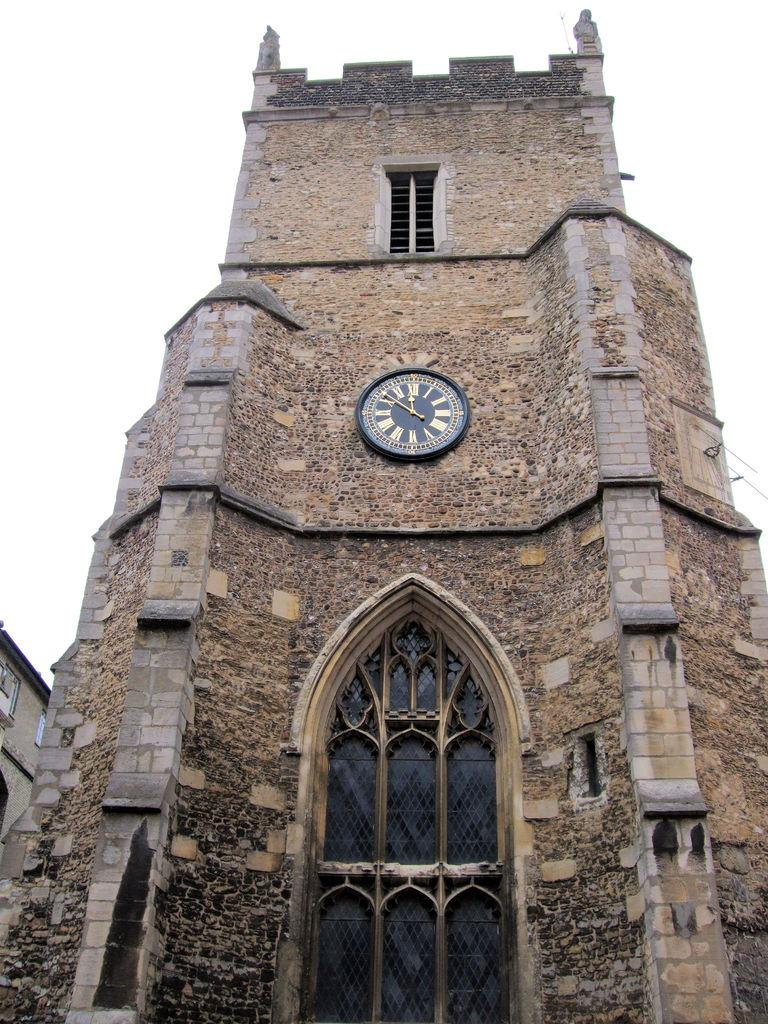<image>
Give a short and clear explanation of the subsequent image. Clock on an old building with the hands on the 12 and 10. 